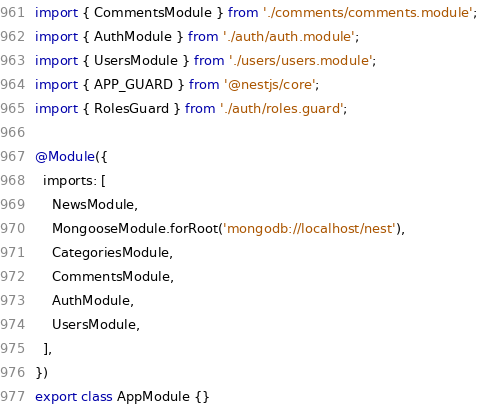<code> <loc_0><loc_0><loc_500><loc_500><_TypeScript_>import { CommentsModule } from './comments/comments.module';
import { AuthModule } from './auth/auth.module';
import { UsersModule } from './users/users.module';
import { APP_GUARD } from '@nestjs/core';
import { RolesGuard } from './auth/roles.guard';

@Module({
  imports: [
    NewsModule,
    MongooseModule.forRoot('mongodb://localhost/nest'),
    CategoriesModule,
    CommentsModule,
    AuthModule,
    UsersModule,
  ],
})
export class AppModule {}
</code> 